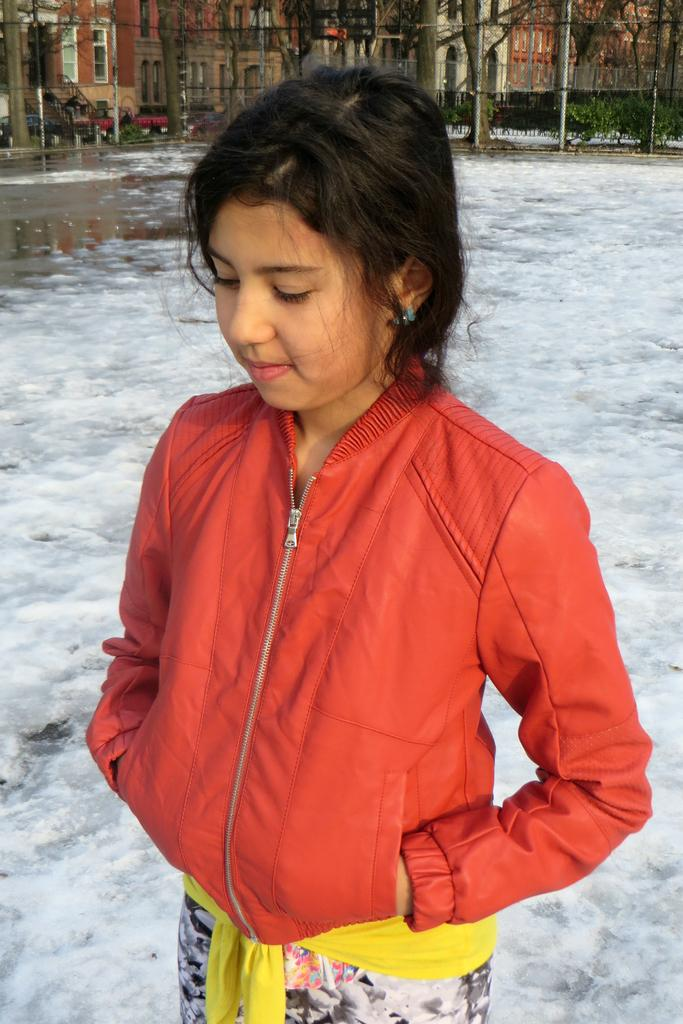What is the child doing in the image? The child is standing in the ice. What can be seen in the background of the image? There are buildings with windows, water, stairs, the bark of trees, plants, a fence, and poles visible in the background. Can you describe the buildings in the background? The buildings have windows, but no specific details about their design or architecture are provided. What type of heat source is being used by the child in the image? There is no heat source visible in the image; the child is standing in the ice. What is the child feeling ashamed about in the image? There is no indication in the image that the child is feeling shame or any other emotion. 